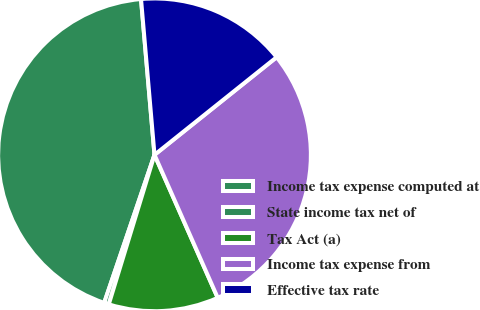<chart> <loc_0><loc_0><loc_500><loc_500><pie_chart><fcel>Income tax expense computed at<fcel>State income tax net of<fcel>Tax Act (a)<fcel>Income tax expense from<fcel>Effective tax rate<nl><fcel>43.41%<fcel>0.49%<fcel>11.35%<fcel>29.11%<fcel>15.64%<nl></chart> 